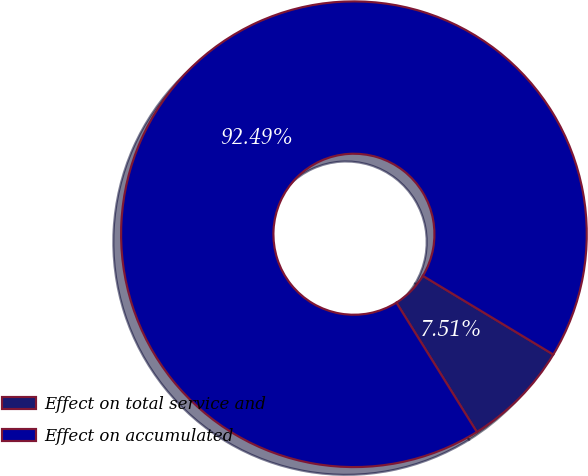<chart> <loc_0><loc_0><loc_500><loc_500><pie_chart><fcel>Effect on total service and<fcel>Effect on accumulated<nl><fcel>7.51%<fcel>92.49%<nl></chart> 